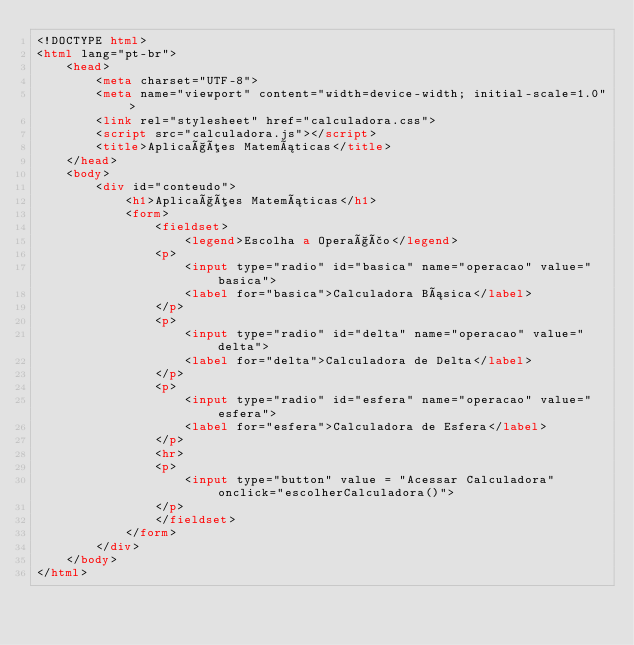Convert code to text. <code><loc_0><loc_0><loc_500><loc_500><_HTML_><!DOCTYPE html>
<html lang="pt-br">
    <head>
        <meta charset="UTF-8">
        <meta name="viewport" content="width=device-width; initial-scale=1.0">
        <link rel="stylesheet" href="calculadora.css">
        <script src="calculadora.js"></script>
        <title>Aplicações Matemáticas</title>
    </head>
    <body>
        <div id="conteudo">
            <h1>Aplicações Matemáticas</h1>
            <form>
                <fieldset>
                    <legend>Escolha a Operação</legend>
                <p>
                    <input type="radio" id="basica" name="operacao" value="basica">
                    <label for="basica">Calculadora Básica</label>
                </p>
                <p>
                    <input type="radio" id="delta" name="operacao" value="delta">
                    <label for="delta">Calculadora de Delta</label>
                </p>
                <p>
                    <input type="radio" id="esfera" name="operacao" value="esfera">
                    <label for="esfera">Calculadora de Esfera</label>
                </p>
                <hr>
                <p>
                    <input type="button" value = "Acessar Calculadora" onclick="escolherCalculadora()">
                </p>
                </fieldset>
            </form>
        </div>
    </body>
</html>
</code> 